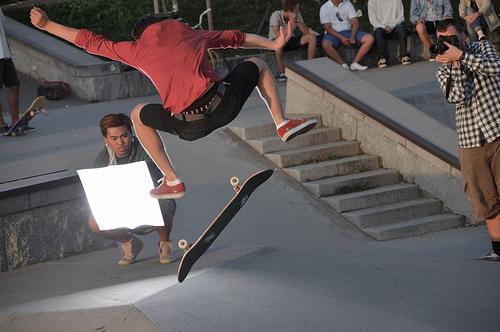How many people are in the air?
Give a very brief answer. 1. 